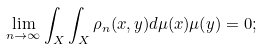Convert formula to latex. <formula><loc_0><loc_0><loc_500><loc_500>\lim _ { n \to \infty } \int _ { X } \int _ { X } \rho _ { n } ( x , y ) d \mu ( x ) \mu ( y ) = 0 ;</formula> 